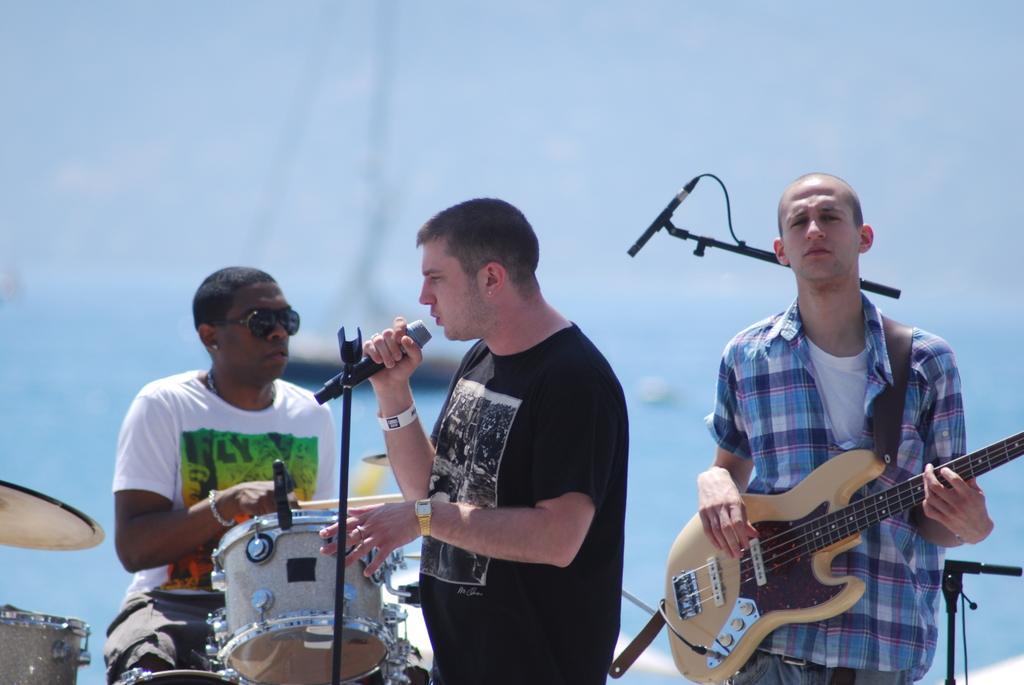In one or two sentences, can you explain what this image depicts? in the picture there are three man,one man is playing guitar,another man is singing in a microphone the third person is sitting and playing drums. 